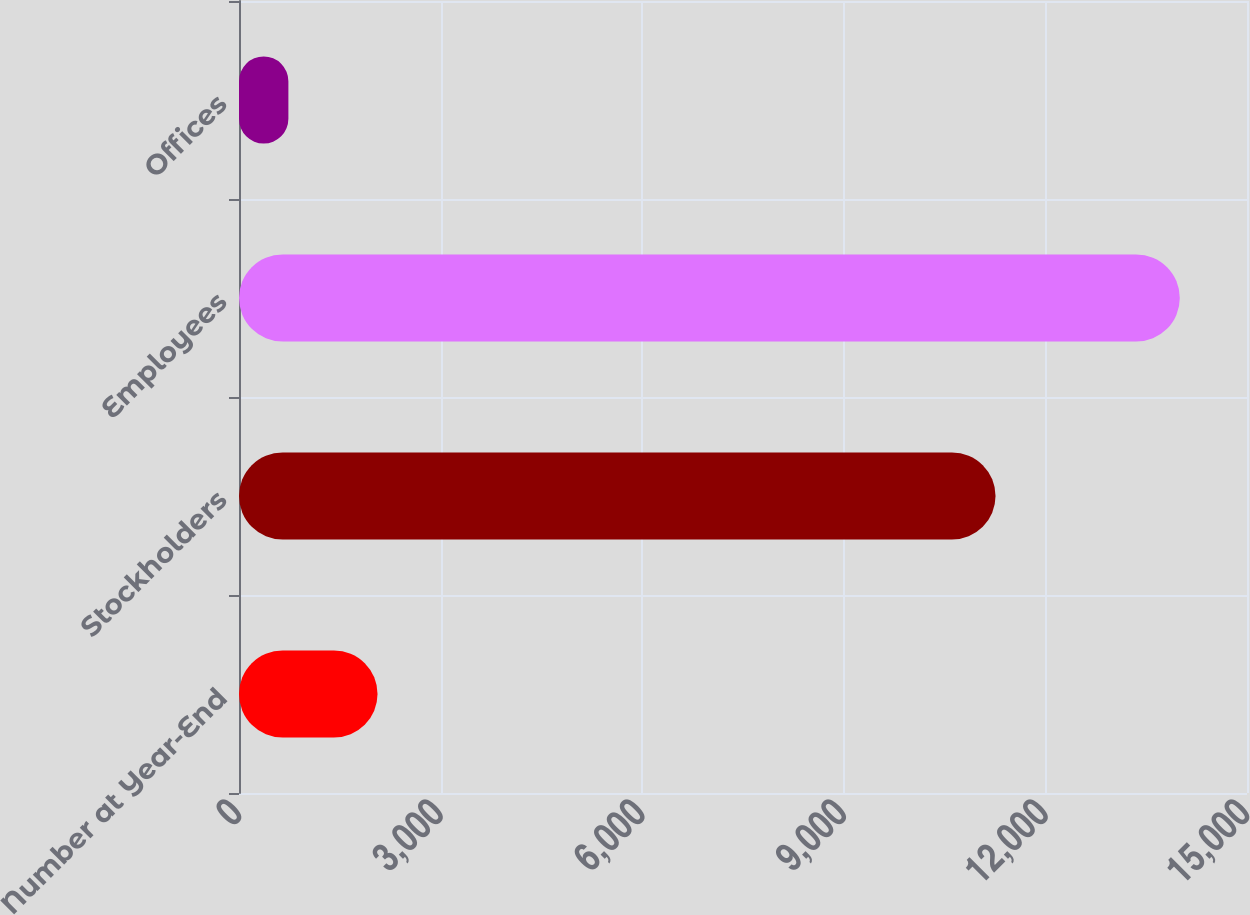<chart> <loc_0><loc_0><loc_500><loc_500><bar_chart><fcel>Number at Year-End<fcel>Stockholders<fcel>Employees<fcel>Offices<nl><fcel>2061.5<fcel>11258<fcel>14000<fcel>735<nl></chart> 